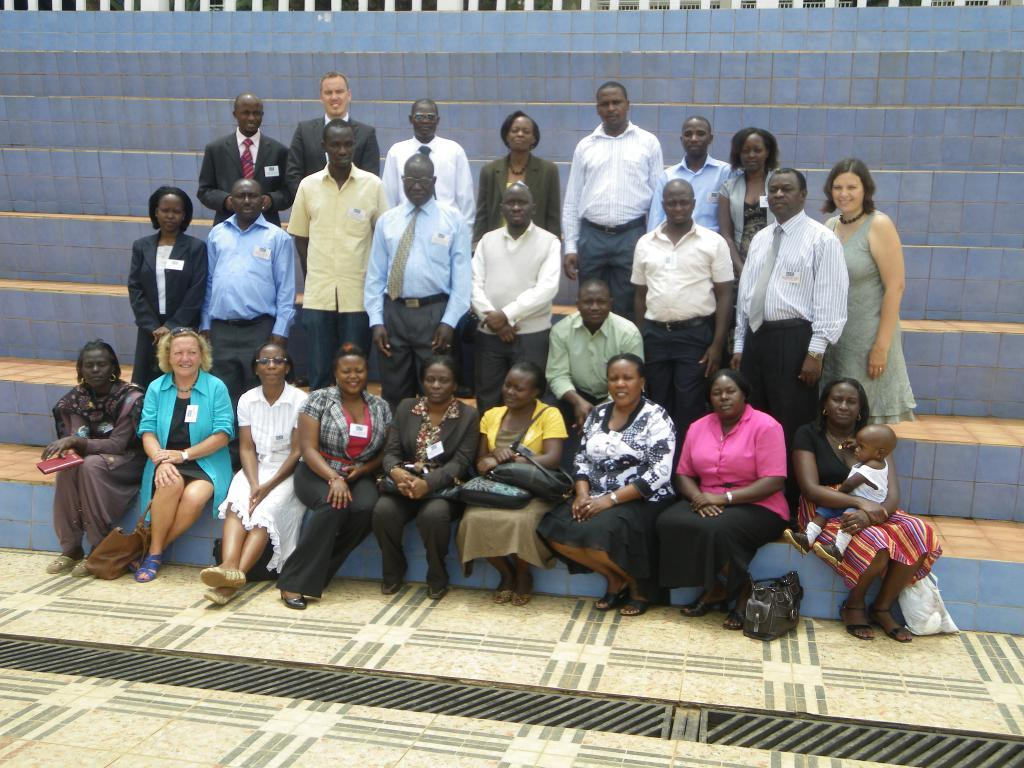How many people are in the image? There are people in the image, but the exact number is not specified. What are some of the people doing in the image? Some people are sitting, and some people are standing. What can be seen in the background of the image? There is a white color fence in the background of the image. What type of spoon is being used by the people in the image? There is no spoon present in the image. Can you describe the texture of the skate that is visible in the image? There is no skate present in the image. 